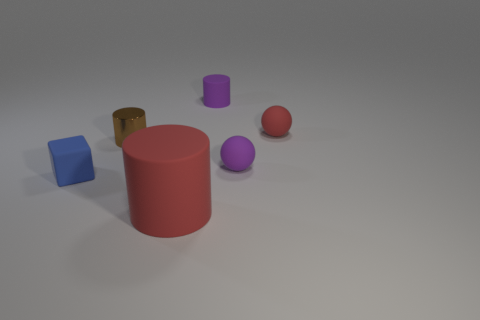Add 2 tiny purple matte spheres. How many objects exist? 8 Subtract all rubber cylinders. How many cylinders are left? 1 Add 3 small metal cylinders. How many small metal cylinders are left? 4 Add 3 yellow metallic cylinders. How many yellow metallic cylinders exist? 3 Subtract all brown cylinders. How many cylinders are left? 2 Subtract 1 blue blocks. How many objects are left? 5 Subtract all blocks. How many objects are left? 5 Subtract 1 cubes. How many cubes are left? 0 Subtract all purple cylinders. Subtract all green balls. How many cylinders are left? 2 Subtract all purple cylinders. How many red spheres are left? 1 